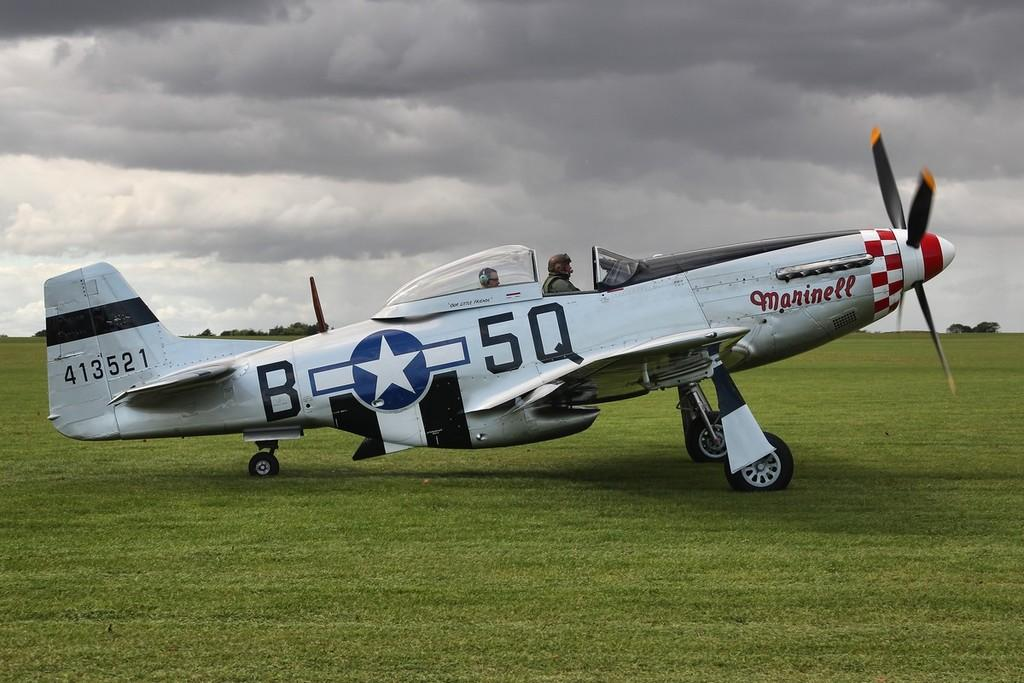What is the main subject of the image? The main subject of the image is an aeroplane. Where is the aeroplane located? The aeroplane is on a grassland. How many people are in the aeroplane? There are two men sitting in the aeroplane. What can be seen in the background of the image? There are trees on both the right and left sides, and the sky is visible with clouds present. What type of beast is the writer holding in the image? There is no beast or writer present in the image; it features an aeroplane on a grassland with two men inside. What answer is the aeroplane providing in the image? The aeroplane is not providing an answer in the image; it is a mode of transportation and not capable of answering questions. 